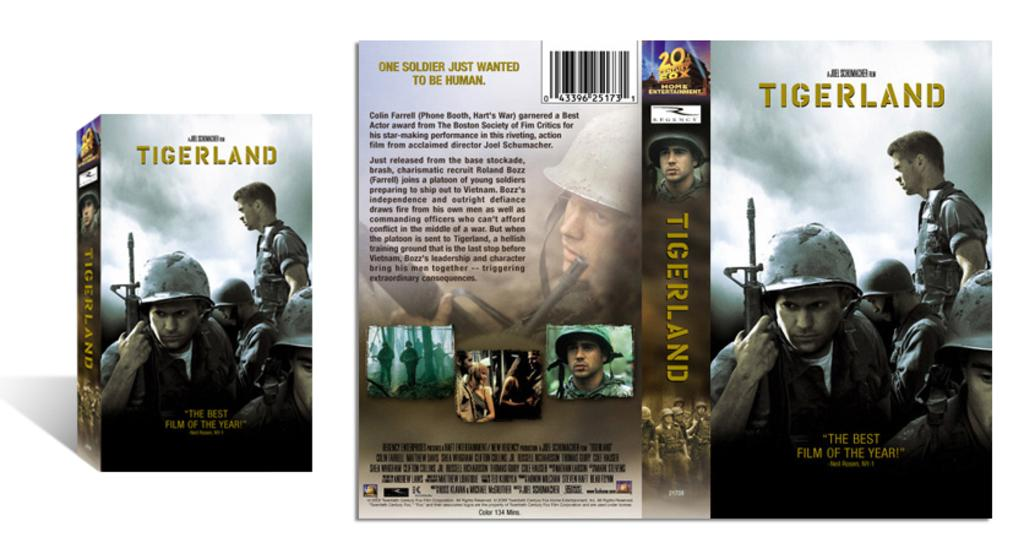<image>
Render a clear and concise summary of the photo. The movie cover for a movie called Tigerland. 